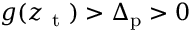<formula> <loc_0><loc_0><loc_500><loc_500>g ( z _ { t } ) > \Delta _ { p } > 0</formula> 